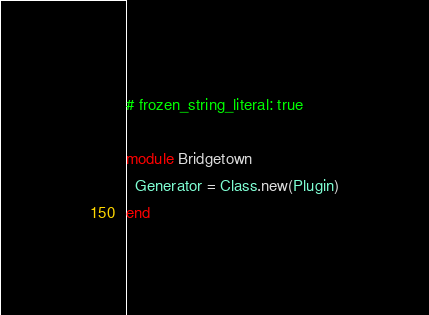<code> <loc_0><loc_0><loc_500><loc_500><_Ruby_># frozen_string_literal: true

module Bridgetown
  Generator = Class.new(Plugin)
end
</code> 